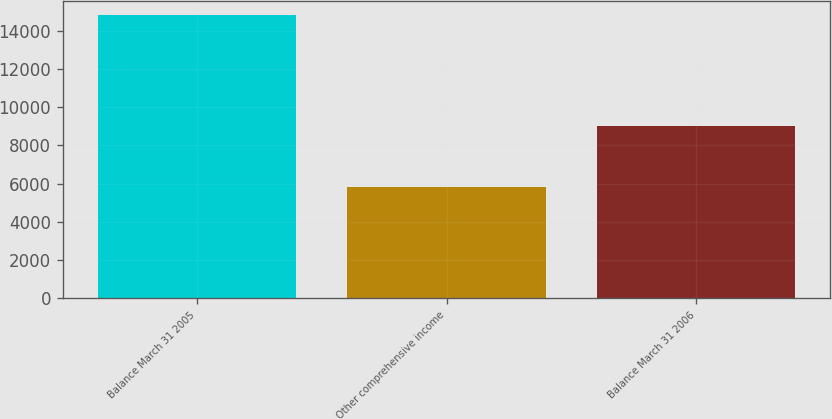Convert chart to OTSL. <chart><loc_0><loc_0><loc_500><loc_500><bar_chart><fcel>Balance March 31 2005<fcel>Other comprehensive income<fcel>Balance March 31 2006<nl><fcel>14838<fcel>5825<fcel>9013<nl></chart> 